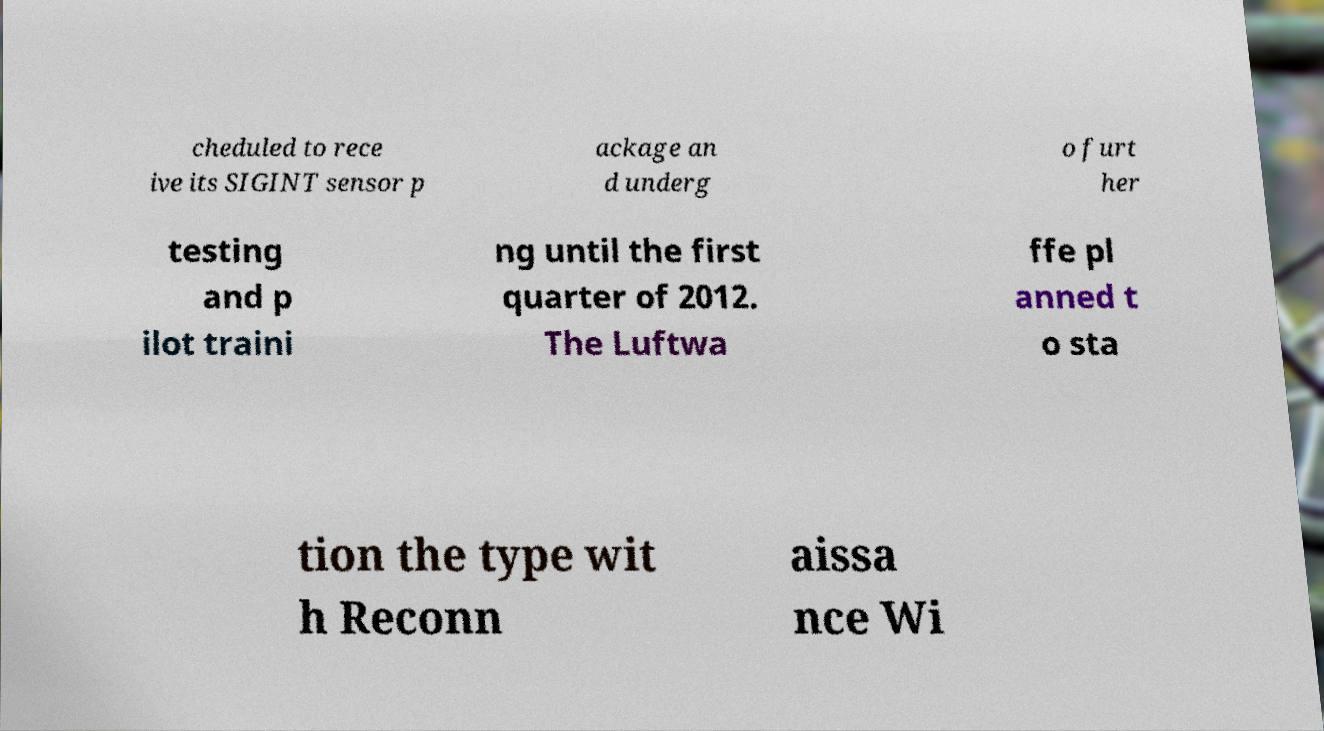For documentation purposes, I need the text within this image transcribed. Could you provide that? cheduled to rece ive its SIGINT sensor p ackage an d underg o furt her testing and p ilot traini ng until the first quarter of 2012. The Luftwa ffe pl anned t o sta tion the type wit h Reconn aissa nce Wi 